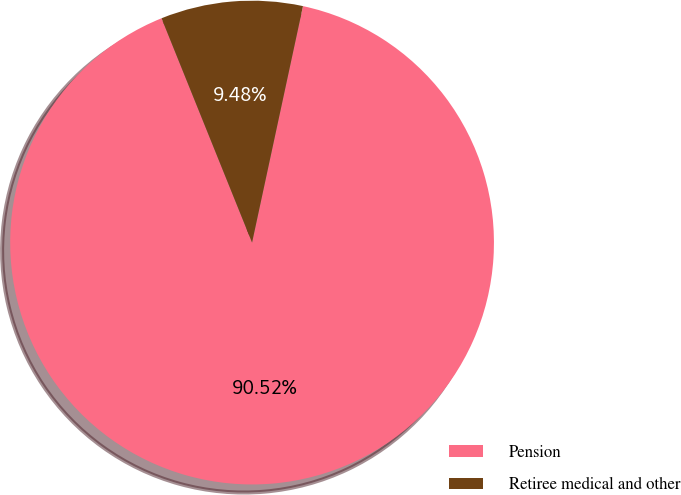<chart> <loc_0><loc_0><loc_500><loc_500><pie_chart><fcel>Pension<fcel>Retiree medical and other<nl><fcel>90.52%<fcel>9.48%<nl></chart> 